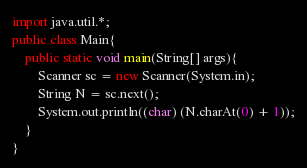<code> <loc_0><loc_0><loc_500><loc_500><_Java_>import java.util.*;
public class Main{
	public static void main(String[] args){
		Scanner sc = new Scanner(System.in);
		String N = sc.next();
		System.out.println((char) (N.charAt(0) + 1));
	}
}</code> 